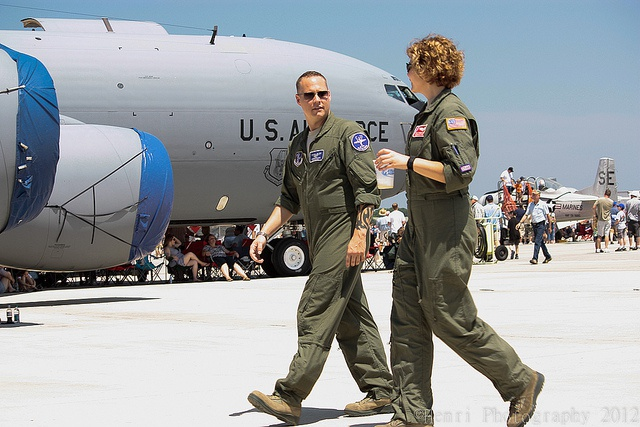Describe the objects in this image and their specific colors. I can see airplane in gray, lightgray, darkgray, and black tones, people in gray, black, and white tones, people in gray and black tones, people in gray, black, and lightgray tones, and airplane in gray, darkgray, lightgray, and black tones in this image. 